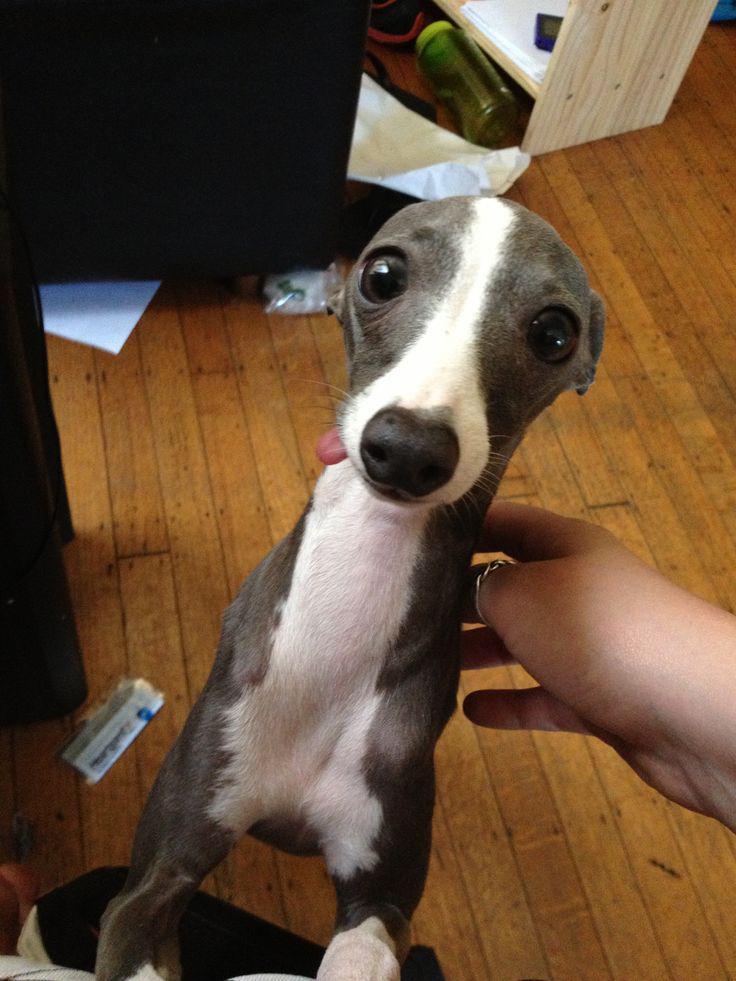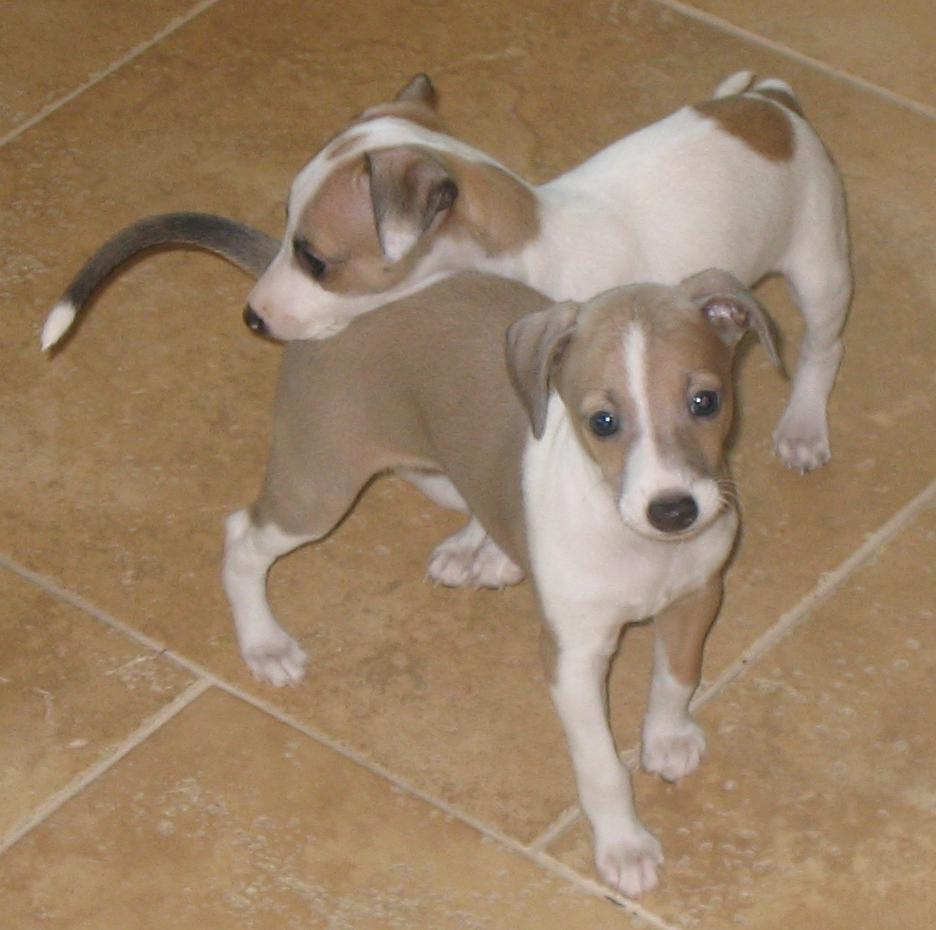The first image is the image on the left, the second image is the image on the right. For the images displayed, is the sentence "Two hounds of different colors are side-by-side on a soft surface, and at least one dog is reclining." factually correct? Answer yes or no. No. The first image is the image on the left, the second image is the image on the right. For the images displayed, is the sentence "The dogs in the image on the right are standing on a tiled floor." factually correct? Answer yes or no. Yes. 